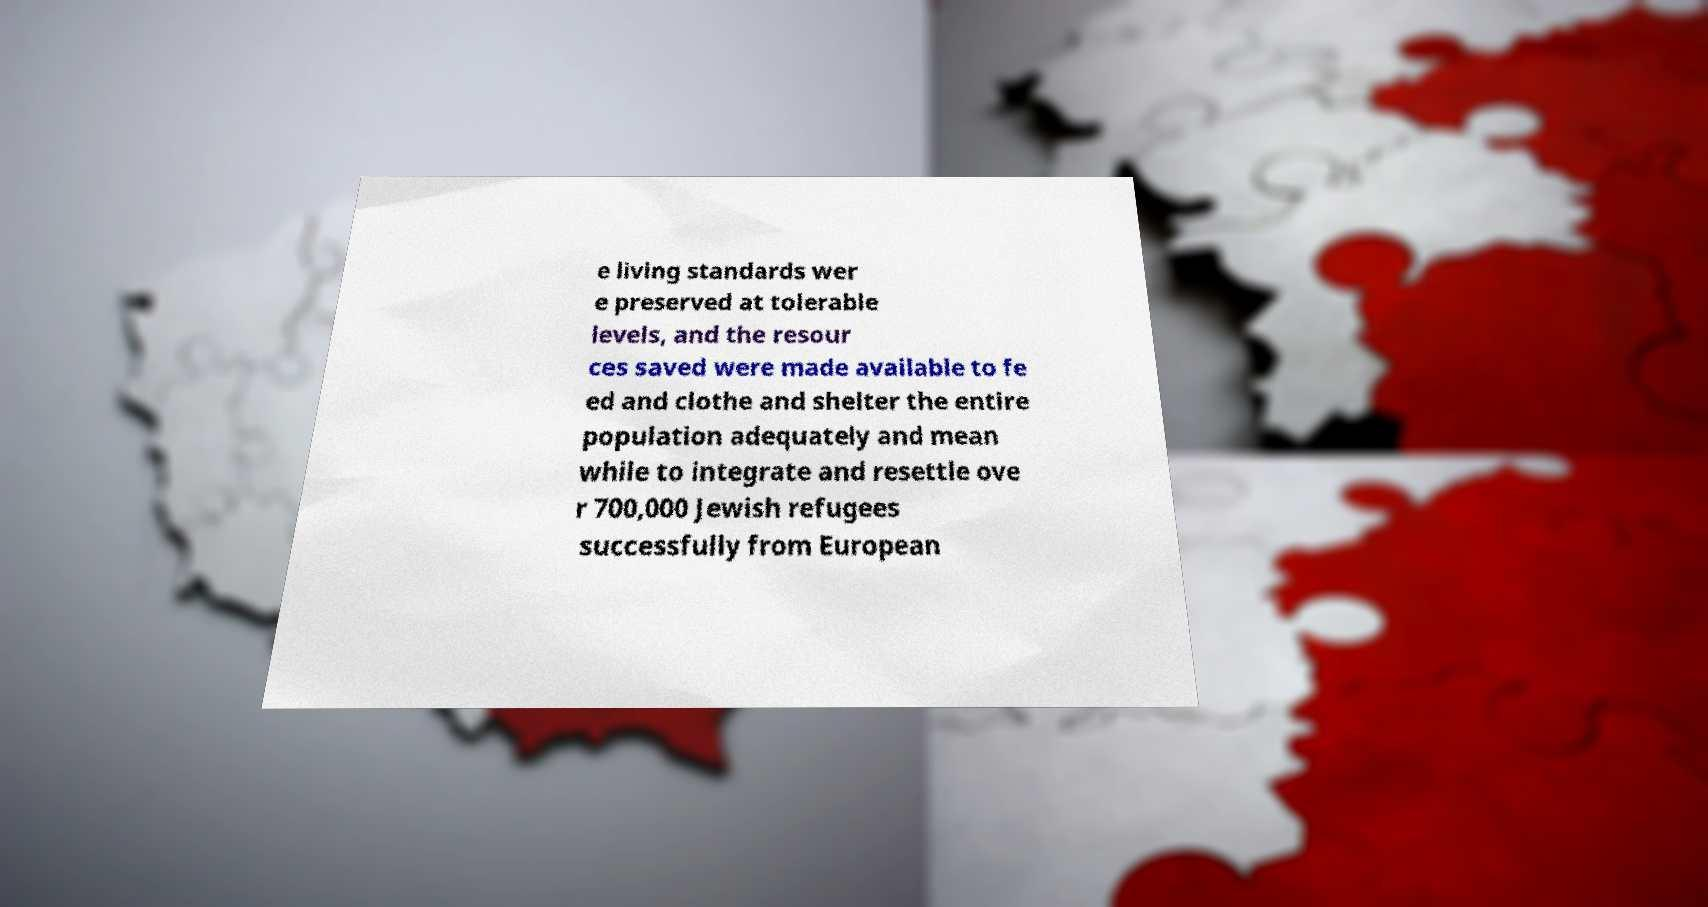For documentation purposes, I need the text within this image transcribed. Could you provide that? e living standards wer e preserved at tolerable levels, and the resour ces saved were made available to fe ed and clothe and shelter the entire population adequately and mean while to integrate and resettle ove r 700,000 Jewish refugees successfully from European 